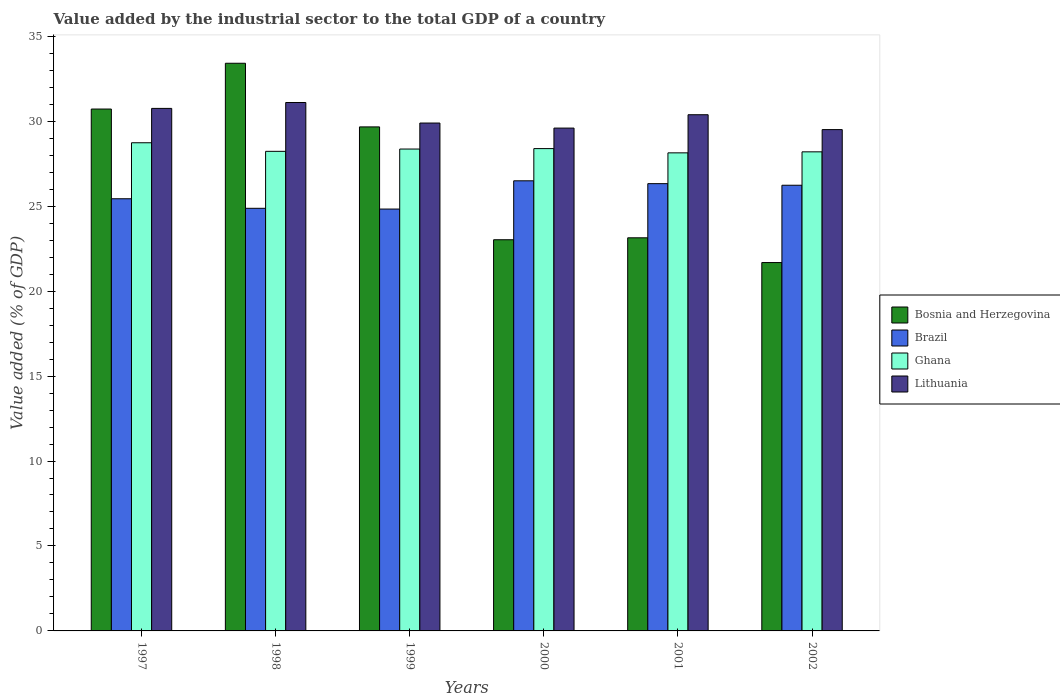How many groups of bars are there?
Provide a short and direct response. 6. How many bars are there on the 1st tick from the left?
Offer a very short reply. 4. In how many cases, is the number of bars for a given year not equal to the number of legend labels?
Keep it short and to the point. 0. What is the value added by the industrial sector to the total GDP in Brazil in 1997?
Your answer should be very brief. 25.44. Across all years, what is the maximum value added by the industrial sector to the total GDP in Ghana?
Ensure brevity in your answer.  28.73. Across all years, what is the minimum value added by the industrial sector to the total GDP in Ghana?
Your response must be concise. 28.14. In which year was the value added by the industrial sector to the total GDP in Brazil minimum?
Keep it short and to the point. 1999. What is the total value added by the industrial sector to the total GDP in Ghana in the graph?
Provide a succinct answer. 170.04. What is the difference between the value added by the industrial sector to the total GDP in Ghana in 1999 and that in 2002?
Provide a succinct answer. 0.16. What is the difference between the value added by the industrial sector to the total GDP in Ghana in 1997 and the value added by the industrial sector to the total GDP in Bosnia and Herzegovina in 2002?
Your response must be concise. 7.05. What is the average value added by the industrial sector to the total GDP in Lithuania per year?
Provide a succinct answer. 30.2. In the year 1999, what is the difference between the value added by the industrial sector to the total GDP in Brazil and value added by the industrial sector to the total GDP in Ghana?
Your answer should be very brief. -3.53. In how many years, is the value added by the industrial sector to the total GDP in Brazil greater than 11 %?
Provide a succinct answer. 6. What is the ratio of the value added by the industrial sector to the total GDP in Lithuania in 1999 to that in 2002?
Give a very brief answer. 1.01. Is the value added by the industrial sector to the total GDP in Lithuania in 2000 less than that in 2002?
Ensure brevity in your answer.  No. Is the difference between the value added by the industrial sector to the total GDP in Brazil in 2001 and 2002 greater than the difference between the value added by the industrial sector to the total GDP in Ghana in 2001 and 2002?
Provide a short and direct response. Yes. What is the difference between the highest and the second highest value added by the industrial sector to the total GDP in Bosnia and Herzegovina?
Offer a very short reply. 2.69. What is the difference between the highest and the lowest value added by the industrial sector to the total GDP in Ghana?
Make the answer very short. 0.59. Is the sum of the value added by the industrial sector to the total GDP in Brazil in 2000 and 2001 greater than the maximum value added by the industrial sector to the total GDP in Bosnia and Herzegovina across all years?
Offer a very short reply. Yes. What does the 3rd bar from the left in 2001 represents?
Provide a short and direct response. Ghana. What does the 1st bar from the right in 1999 represents?
Your answer should be very brief. Lithuania. Is it the case that in every year, the sum of the value added by the industrial sector to the total GDP in Ghana and value added by the industrial sector to the total GDP in Lithuania is greater than the value added by the industrial sector to the total GDP in Brazil?
Your answer should be very brief. Yes. Are all the bars in the graph horizontal?
Ensure brevity in your answer.  No. How many years are there in the graph?
Offer a very short reply. 6. Does the graph contain any zero values?
Your answer should be very brief. No. Does the graph contain grids?
Your response must be concise. No. How are the legend labels stacked?
Provide a succinct answer. Vertical. What is the title of the graph?
Offer a very short reply. Value added by the industrial sector to the total GDP of a country. Does "Europe(developing only)" appear as one of the legend labels in the graph?
Ensure brevity in your answer.  No. What is the label or title of the X-axis?
Offer a terse response. Years. What is the label or title of the Y-axis?
Keep it short and to the point. Value added (% of GDP). What is the Value added (% of GDP) in Bosnia and Herzegovina in 1997?
Offer a very short reply. 30.72. What is the Value added (% of GDP) in Brazil in 1997?
Ensure brevity in your answer.  25.44. What is the Value added (% of GDP) in Ghana in 1997?
Your answer should be very brief. 28.73. What is the Value added (% of GDP) in Lithuania in 1997?
Make the answer very short. 30.75. What is the Value added (% of GDP) of Bosnia and Herzegovina in 1998?
Your answer should be very brief. 33.41. What is the Value added (% of GDP) of Brazil in 1998?
Give a very brief answer. 24.87. What is the Value added (% of GDP) in Ghana in 1998?
Offer a terse response. 28.23. What is the Value added (% of GDP) in Lithuania in 1998?
Provide a short and direct response. 31.1. What is the Value added (% of GDP) in Bosnia and Herzegovina in 1999?
Keep it short and to the point. 29.66. What is the Value added (% of GDP) in Brazil in 1999?
Your response must be concise. 24.83. What is the Value added (% of GDP) of Ghana in 1999?
Keep it short and to the point. 28.36. What is the Value added (% of GDP) of Lithuania in 1999?
Keep it short and to the point. 29.89. What is the Value added (% of GDP) of Bosnia and Herzegovina in 2000?
Make the answer very short. 23.02. What is the Value added (% of GDP) of Brazil in 2000?
Provide a succinct answer. 26.49. What is the Value added (% of GDP) of Ghana in 2000?
Your answer should be compact. 28.39. What is the Value added (% of GDP) of Lithuania in 2000?
Give a very brief answer. 29.6. What is the Value added (% of GDP) in Bosnia and Herzegovina in 2001?
Offer a terse response. 23.14. What is the Value added (% of GDP) of Brazil in 2001?
Ensure brevity in your answer.  26.32. What is the Value added (% of GDP) in Ghana in 2001?
Your answer should be compact. 28.14. What is the Value added (% of GDP) in Lithuania in 2001?
Offer a very short reply. 30.38. What is the Value added (% of GDP) in Bosnia and Herzegovina in 2002?
Give a very brief answer. 21.68. What is the Value added (% of GDP) in Brazil in 2002?
Give a very brief answer. 26.23. What is the Value added (% of GDP) of Ghana in 2002?
Offer a very short reply. 28.2. What is the Value added (% of GDP) in Lithuania in 2002?
Ensure brevity in your answer.  29.51. Across all years, what is the maximum Value added (% of GDP) of Bosnia and Herzegovina?
Give a very brief answer. 33.41. Across all years, what is the maximum Value added (% of GDP) in Brazil?
Make the answer very short. 26.49. Across all years, what is the maximum Value added (% of GDP) of Ghana?
Your answer should be very brief. 28.73. Across all years, what is the maximum Value added (% of GDP) of Lithuania?
Keep it short and to the point. 31.1. Across all years, what is the minimum Value added (% of GDP) of Bosnia and Herzegovina?
Offer a terse response. 21.68. Across all years, what is the minimum Value added (% of GDP) of Brazil?
Give a very brief answer. 24.83. Across all years, what is the minimum Value added (% of GDP) of Ghana?
Your response must be concise. 28.14. Across all years, what is the minimum Value added (% of GDP) in Lithuania?
Provide a succinct answer. 29.51. What is the total Value added (% of GDP) of Bosnia and Herzegovina in the graph?
Keep it short and to the point. 161.63. What is the total Value added (% of GDP) in Brazil in the graph?
Your response must be concise. 154.19. What is the total Value added (% of GDP) in Ghana in the graph?
Offer a terse response. 170.04. What is the total Value added (% of GDP) in Lithuania in the graph?
Offer a very short reply. 181.23. What is the difference between the Value added (% of GDP) in Bosnia and Herzegovina in 1997 and that in 1998?
Offer a very short reply. -2.69. What is the difference between the Value added (% of GDP) in Brazil in 1997 and that in 1998?
Your answer should be compact. 0.56. What is the difference between the Value added (% of GDP) in Ghana in 1997 and that in 1998?
Offer a terse response. 0.51. What is the difference between the Value added (% of GDP) of Lithuania in 1997 and that in 1998?
Your answer should be compact. -0.35. What is the difference between the Value added (% of GDP) in Bosnia and Herzegovina in 1997 and that in 1999?
Provide a short and direct response. 1.05. What is the difference between the Value added (% of GDP) of Brazil in 1997 and that in 1999?
Provide a succinct answer. 0.61. What is the difference between the Value added (% of GDP) in Ghana in 1997 and that in 1999?
Offer a very short reply. 0.37. What is the difference between the Value added (% of GDP) in Lithuania in 1997 and that in 1999?
Provide a succinct answer. 0.86. What is the difference between the Value added (% of GDP) in Bosnia and Herzegovina in 1997 and that in 2000?
Provide a succinct answer. 7.69. What is the difference between the Value added (% of GDP) in Brazil in 1997 and that in 2000?
Keep it short and to the point. -1.06. What is the difference between the Value added (% of GDP) of Ghana in 1997 and that in 2000?
Your answer should be compact. 0.34. What is the difference between the Value added (% of GDP) of Lithuania in 1997 and that in 2000?
Provide a short and direct response. 1.16. What is the difference between the Value added (% of GDP) of Bosnia and Herzegovina in 1997 and that in 2001?
Make the answer very short. 7.58. What is the difference between the Value added (% of GDP) in Brazil in 1997 and that in 2001?
Your answer should be compact. -0.89. What is the difference between the Value added (% of GDP) in Ghana in 1997 and that in 2001?
Give a very brief answer. 0.59. What is the difference between the Value added (% of GDP) in Lithuania in 1997 and that in 2001?
Provide a short and direct response. 0.37. What is the difference between the Value added (% of GDP) in Bosnia and Herzegovina in 1997 and that in 2002?
Your answer should be compact. 9.03. What is the difference between the Value added (% of GDP) of Brazil in 1997 and that in 2002?
Give a very brief answer. -0.79. What is the difference between the Value added (% of GDP) in Ghana in 1997 and that in 2002?
Provide a succinct answer. 0.53. What is the difference between the Value added (% of GDP) in Lithuania in 1997 and that in 2002?
Make the answer very short. 1.25. What is the difference between the Value added (% of GDP) in Bosnia and Herzegovina in 1998 and that in 1999?
Your response must be concise. 3.75. What is the difference between the Value added (% of GDP) in Brazil in 1998 and that in 1999?
Your answer should be compact. 0.04. What is the difference between the Value added (% of GDP) in Ghana in 1998 and that in 1999?
Offer a very short reply. -0.14. What is the difference between the Value added (% of GDP) in Lithuania in 1998 and that in 1999?
Your answer should be compact. 1.21. What is the difference between the Value added (% of GDP) in Bosnia and Herzegovina in 1998 and that in 2000?
Ensure brevity in your answer.  10.39. What is the difference between the Value added (% of GDP) of Brazil in 1998 and that in 2000?
Your answer should be very brief. -1.62. What is the difference between the Value added (% of GDP) in Ghana in 1998 and that in 2000?
Ensure brevity in your answer.  -0.16. What is the difference between the Value added (% of GDP) in Lithuania in 1998 and that in 2000?
Your answer should be compact. 1.51. What is the difference between the Value added (% of GDP) of Bosnia and Herzegovina in 1998 and that in 2001?
Offer a very short reply. 10.27. What is the difference between the Value added (% of GDP) in Brazil in 1998 and that in 2001?
Provide a succinct answer. -1.45. What is the difference between the Value added (% of GDP) of Ghana in 1998 and that in 2001?
Your response must be concise. 0.09. What is the difference between the Value added (% of GDP) in Lithuania in 1998 and that in 2001?
Keep it short and to the point. 0.72. What is the difference between the Value added (% of GDP) in Bosnia and Herzegovina in 1998 and that in 2002?
Offer a very short reply. 11.73. What is the difference between the Value added (% of GDP) in Brazil in 1998 and that in 2002?
Your answer should be compact. -1.36. What is the difference between the Value added (% of GDP) of Ghana in 1998 and that in 2002?
Your response must be concise. 0.03. What is the difference between the Value added (% of GDP) in Lithuania in 1998 and that in 2002?
Your answer should be compact. 1.6. What is the difference between the Value added (% of GDP) of Bosnia and Herzegovina in 1999 and that in 2000?
Your answer should be compact. 6.64. What is the difference between the Value added (% of GDP) of Brazil in 1999 and that in 2000?
Provide a succinct answer. -1.66. What is the difference between the Value added (% of GDP) in Ghana in 1999 and that in 2000?
Your answer should be very brief. -0.03. What is the difference between the Value added (% of GDP) in Lithuania in 1999 and that in 2000?
Give a very brief answer. 0.3. What is the difference between the Value added (% of GDP) of Bosnia and Herzegovina in 1999 and that in 2001?
Your response must be concise. 6.53. What is the difference between the Value added (% of GDP) in Brazil in 1999 and that in 2001?
Give a very brief answer. -1.49. What is the difference between the Value added (% of GDP) of Ghana in 1999 and that in 2001?
Offer a very short reply. 0.22. What is the difference between the Value added (% of GDP) of Lithuania in 1999 and that in 2001?
Your answer should be compact. -0.49. What is the difference between the Value added (% of GDP) of Bosnia and Herzegovina in 1999 and that in 2002?
Provide a succinct answer. 7.98. What is the difference between the Value added (% of GDP) of Brazil in 1999 and that in 2002?
Provide a succinct answer. -1.4. What is the difference between the Value added (% of GDP) in Ghana in 1999 and that in 2002?
Offer a terse response. 0.16. What is the difference between the Value added (% of GDP) in Lithuania in 1999 and that in 2002?
Your answer should be very brief. 0.39. What is the difference between the Value added (% of GDP) of Bosnia and Herzegovina in 2000 and that in 2001?
Offer a very short reply. -0.11. What is the difference between the Value added (% of GDP) of Brazil in 2000 and that in 2001?
Give a very brief answer. 0.17. What is the difference between the Value added (% of GDP) of Ghana in 2000 and that in 2001?
Offer a very short reply. 0.25. What is the difference between the Value added (% of GDP) in Lithuania in 2000 and that in 2001?
Keep it short and to the point. -0.79. What is the difference between the Value added (% of GDP) in Bosnia and Herzegovina in 2000 and that in 2002?
Ensure brevity in your answer.  1.34. What is the difference between the Value added (% of GDP) of Brazil in 2000 and that in 2002?
Your response must be concise. 0.26. What is the difference between the Value added (% of GDP) of Ghana in 2000 and that in 2002?
Give a very brief answer. 0.19. What is the difference between the Value added (% of GDP) of Lithuania in 2000 and that in 2002?
Provide a short and direct response. 0.09. What is the difference between the Value added (% of GDP) of Bosnia and Herzegovina in 2001 and that in 2002?
Your answer should be compact. 1.46. What is the difference between the Value added (% of GDP) of Brazil in 2001 and that in 2002?
Ensure brevity in your answer.  0.09. What is the difference between the Value added (% of GDP) in Ghana in 2001 and that in 2002?
Provide a succinct answer. -0.06. What is the difference between the Value added (% of GDP) in Lithuania in 2001 and that in 2002?
Keep it short and to the point. 0.88. What is the difference between the Value added (% of GDP) of Bosnia and Herzegovina in 1997 and the Value added (% of GDP) of Brazil in 1998?
Provide a succinct answer. 5.84. What is the difference between the Value added (% of GDP) of Bosnia and Herzegovina in 1997 and the Value added (% of GDP) of Ghana in 1998?
Keep it short and to the point. 2.49. What is the difference between the Value added (% of GDP) in Bosnia and Herzegovina in 1997 and the Value added (% of GDP) in Lithuania in 1998?
Offer a terse response. -0.39. What is the difference between the Value added (% of GDP) in Brazil in 1997 and the Value added (% of GDP) in Ghana in 1998?
Ensure brevity in your answer.  -2.79. What is the difference between the Value added (% of GDP) of Brazil in 1997 and the Value added (% of GDP) of Lithuania in 1998?
Keep it short and to the point. -5.66. What is the difference between the Value added (% of GDP) in Ghana in 1997 and the Value added (% of GDP) in Lithuania in 1998?
Keep it short and to the point. -2.37. What is the difference between the Value added (% of GDP) of Bosnia and Herzegovina in 1997 and the Value added (% of GDP) of Brazil in 1999?
Provide a succinct answer. 5.89. What is the difference between the Value added (% of GDP) in Bosnia and Herzegovina in 1997 and the Value added (% of GDP) in Ghana in 1999?
Provide a short and direct response. 2.35. What is the difference between the Value added (% of GDP) in Bosnia and Herzegovina in 1997 and the Value added (% of GDP) in Lithuania in 1999?
Keep it short and to the point. 0.82. What is the difference between the Value added (% of GDP) in Brazil in 1997 and the Value added (% of GDP) in Ghana in 1999?
Offer a very short reply. -2.93. What is the difference between the Value added (% of GDP) of Brazil in 1997 and the Value added (% of GDP) of Lithuania in 1999?
Provide a short and direct response. -4.46. What is the difference between the Value added (% of GDP) of Ghana in 1997 and the Value added (% of GDP) of Lithuania in 1999?
Offer a very short reply. -1.16. What is the difference between the Value added (% of GDP) of Bosnia and Herzegovina in 1997 and the Value added (% of GDP) of Brazil in 2000?
Your response must be concise. 4.22. What is the difference between the Value added (% of GDP) in Bosnia and Herzegovina in 1997 and the Value added (% of GDP) in Ghana in 2000?
Make the answer very short. 2.33. What is the difference between the Value added (% of GDP) of Bosnia and Herzegovina in 1997 and the Value added (% of GDP) of Lithuania in 2000?
Your answer should be very brief. 1.12. What is the difference between the Value added (% of GDP) of Brazil in 1997 and the Value added (% of GDP) of Ghana in 2000?
Your answer should be very brief. -2.95. What is the difference between the Value added (% of GDP) in Brazil in 1997 and the Value added (% of GDP) in Lithuania in 2000?
Keep it short and to the point. -4.16. What is the difference between the Value added (% of GDP) in Ghana in 1997 and the Value added (% of GDP) in Lithuania in 2000?
Keep it short and to the point. -0.86. What is the difference between the Value added (% of GDP) of Bosnia and Herzegovina in 1997 and the Value added (% of GDP) of Brazil in 2001?
Give a very brief answer. 4.39. What is the difference between the Value added (% of GDP) in Bosnia and Herzegovina in 1997 and the Value added (% of GDP) in Ghana in 2001?
Offer a very short reply. 2.58. What is the difference between the Value added (% of GDP) in Bosnia and Herzegovina in 1997 and the Value added (% of GDP) in Lithuania in 2001?
Your answer should be compact. 0.33. What is the difference between the Value added (% of GDP) in Brazil in 1997 and the Value added (% of GDP) in Ghana in 2001?
Offer a very short reply. -2.7. What is the difference between the Value added (% of GDP) of Brazil in 1997 and the Value added (% of GDP) of Lithuania in 2001?
Your response must be concise. -4.95. What is the difference between the Value added (% of GDP) in Ghana in 1997 and the Value added (% of GDP) in Lithuania in 2001?
Provide a short and direct response. -1.65. What is the difference between the Value added (% of GDP) in Bosnia and Herzegovina in 1997 and the Value added (% of GDP) in Brazil in 2002?
Your answer should be very brief. 4.48. What is the difference between the Value added (% of GDP) in Bosnia and Herzegovina in 1997 and the Value added (% of GDP) in Ghana in 2002?
Make the answer very short. 2.52. What is the difference between the Value added (% of GDP) of Bosnia and Herzegovina in 1997 and the Value added (% of GDP) of Lithuania in 2002?
Offer a terse response. 1.21. What is the difference between the Value added (% of GDP) in Brazil in 1997 and the Value added (% of GDP) in Ghana in 2002?
Offer a very short reply. -2.76. What is the difference between the Value added (% of GDP) of Brazil in 1997 and the Value added (% of GDP) of Lithuania in 2002?
Offer a terse response. -4.07. What is the difference between the Value added (% of GDP) of Ghana in 1997 and the Value added (% of GDP) of Lithuania in 2002?
Provide a succinct answer. -0.77. What is the difference between the Value added (% of GDP) of Bosnia and Herzegovina in 1998 and the Value added (% of GDP) of Brazil in 1999?
Provide a short and direct response. 8.58. What is the difference between the Value added (% of GDP) in Bosnia and Herzegovina in 1998 and the Value added (% of GDP) in Ghana in 1999?
Keep it short and to the point. 5.05. What is the difference between the Value added (% of GDP) of Bosnia and Herzegovina in 1998 and the Value added (% of GDP) of Lithuania in 1999?
Ensure brevity in your answer.  3.52. What is the difference between the Value added (% of GDP) of Brazil in 1998 and the Value added (% of GDP) of Ghana in 1999?
Keep it short and to the point. -3.49. What is the difference between the Value added (% of GDP) in Brazil in 1998 and the Value added (% of GDP) in Lithuania in 1999?
Give a very brief answer. -5.02. What is the difference between the Value added (% of GDP) of Ghana in 1998 and the Value added (% of GDP) of Lithuania in 1999?
Give a very brief answer. -1.67. What is the difference between the Value added (% of GDP) in Bosnia and Herzegovina in 1998 and the Value added (% of GDP) in Brazil in 2000?
Offer a very short reply. 6.92. What is the difference between the Value added (% of GDP) of Bosnia and Herzegovina in 1998 and the Value added (% of GDP) of Ghana in 2000?
Make the answer very short. 5.02. What is the difference between the Value added (% of GDP) in Bosnia and Herzegovina in 1998 and the Value added (% of GDP) in Lithuania in 2000?
Ensure brevity in your answer.  3.82. What is the difference between the Value added (% of GDP) of Brazil in 1998 and the Value added (% of GDP) of Ghana in 2000?
Make the answer very short. -3.51. What is the difference between the Value added (% of GDP) of Brazil in 1998 and the Value added (% of GDP) of Lithuania in 2000?
Provide a succinct answer. -4.72. What is the difference between the Value added (% of GDP) of Ghana in 1998 and the Value added (% of GDP) of Lithuania in 2000?
Make the answer very short. -1.37. What is the difference between the Value added (% of GDP) of Bosnia and Herzegovina in 1998 and the Value added (% of GDP) of Brazil in 2001?
Ensure brevity in your answer.  7.09. What is the difference between the Value added (% of GDP) in Bosnia and Herzegovina in 1998 and the Value added (% of GDP) in Ghana in 2001?
Provide a succinct answer. 5.27. What is the difference between the Value added (% of GDP) of Bosnia and Herzegovina in 1998 and the Value added (% of GDP) of Lithuania in 2001?
Provide a succinct answer. 3.03. What is the difference between the Value added (% of GDP) in Brazil in 1998 and the Value added (% of GDP) in Ghana in 2001?
Provide a succinct answer. -3.26. What is the difference between the Value added (% of GDP) in Brazil in 1998 and the Value added (% of GDP) in Lithuania in 2001?
Your response must be concise. -5.51. What is the difference between the Value added (% of GDP) in Ghana in 1998 and the Value added (% of GDP) in Lithuania in 2001?
Offer a very short reply. -2.15. What is the difference between the Value added (% of GDP) of Bosnia and Herzegovina in 1998 and the Value added (% of GDP) of Brazil in 2002?
Offer a terse response. 7.18. What is the difference between the Value added (% of GDP) of Bosnia and Herzegovina in 1998 and the Value added (% of GDP) of Ghana in 2002?
Your answer should be compact. 5.21. What is the difference between the Value added (% of GDP) in Bosnia and Herzegovina in 1998 and the Value added (% of GDP) in Lithuania in 2002?
Make the answer very short. 3.9. What is the difference between the Value added (% of GDP) of Brazil in 1998 and the Value added (% of GDP) of Ghana in 2002?
Give a very brief answer. -3.32. What is the difference between the Value added (% of GDP) of Brazil in 1998 and the Value added (% of GDP) of Lithuania in 2002?
Make the answer very short. -4.63. What is the difference between the Value added (% of GDP) in Ghana in 1998 and the Value added (% of GDP) in Lithuania in 2002?
Your response must be concise. -1.28. What is the difference between the Value added (% of GDP) of Bosnia and Herzegovina in 1999 and the Value added (% of GDP) of Brazil in 2000?
Provide a short and direct response. 3.17. What is the difference between the Value added (% of GDP) in Bosnia and Herzegovina in 1999 and the Value added (% of GDP) in Ghana in 2000?
Provide a short and direct response. 1.28. What is the difference between the Value added (% of GDP) in Bosnia and Herzegovina in 1999 and the Value added (% of GDP) in Lithuania in 2000?
Make the answer very short. 0.07. What is the difference between the Value added (% of GDP) in Brazil in 1999 and the Value added (% of GDP) in Ghana in 2000?
Offer a very short reply. -3.56. What is the difference between the Value added (% of GDP) of Brazil in 1999 and the Value added (% of GDP) of Lithuania in 2000?
Ensure brevity in your answer.  -4.77. What is the difference between the Value added (% of GDP) of Ghana in 1999 and the Value added (% of GDP) of Lithuania in 2000?
Provide a succinct answer. -1.23. What is the difference between the Value added (% of GDP) in Bosnia and Herzegovina in 1999 and the Value added (% of GDP) in Brazil in 2001?
Make the answer very short. 3.34. What is the difference between the Value added (% of GDP) of Bosnia and Herzegovina in 1999 and the Value added (% of GDP) of Ghana in 2001?
Your answer should be very brief. 1.53. What is the difference between the Value added (% of GDP) in Bosnia and Herzegovina in 1999 and the Value added (% of GDP) in Lithuania in 2001?
Keep it short and to the point. -0.72. What is the difference between the Value added (% of GDP) of Brazil in 1999 and the Value added (% of GDP) of Ghana in 2001?
Your answer should be very brief. -3.31. What is the difference between the Value added (% of GDP) of Brazil in 1999 and the Value added (% of GDP) of Lithuania in 2001?
Offer a very short reply. -5.55. What is the difference between the Value added (% of GDP) in Ghana in 1999 and the Value added (% of GDP) in Lithuania in 2001?
Make the answer very short. -2.02. What is the difference between the Value added (% of GDP) of Bosnia and Herzegovina in 1999 and the Value added (% of GDP) of Brazil in 2002?
Make the answer very short. 3.43. What is the difference between the Value added (% of GDP) of Bosnia and Herzegovina in 1999 and the Value added (% of GDP) of Ghana in 2002?
Ensure brevity in your answer.  1.47. What is the difference between the Value added (% of GDP) in Bosnia and Herzegovina in 1999 and the Value added (% of GDP) in Lithuania in 2002?
Keep it short and to the point. 0.16. What is the difference between the Value added (% of GDP) of Brazil in 1999 and the Value added (% of GDP) of Ghana in 2002?
Keep it short and to the point. -3.37. What is the difference between the Value added (% of GDP) of Brazil in 1999 and the Value added (% of GDP) of Lithuania in 2002?
Offer a very short reply. -4.68. What is the difference between the Value added (% of GDP) in Ghana in 1999 and the Value added (% of GDP) in Lithuania in 2002?
Offer a very short reply. -1.14. What is the difference between the Value added (% of GDP) of Bosnia and Herzegovina in 2000 and the Value added (% of GDP) of Brazil in 2001?
Your answer should be compact. -3.3. What is the difference between the Value added (% of GDP) in Bosnia and Herzegovina in 2000 and the Value added (% of GDP) in Ghana in 2001?
Make the answer very short. -5.11. What is the difference between the Value added (% of GDP) of Bosnia and Herzegovina in 2000 and the Value added (% of GDP) of Lithuania in 2001?
Your answer should be very brief. -7.36. What is the difference between the Value added (% of GDP) in Brazil in 2000 and the Value added (% of GDP) in Ghana in 2001?
Give a very brief answer. -1.65. What is the difference between the Value added (% of GDP) in Brazil in 2000 and the Value added (% of GDP) in Lithuania in 2001?
Ensure brevity in your answer.  -3.89. What is the difference between the Value added (% of GDP) of Ghana in 2000 and the Value added (% of GDP) of Lithuania in 2001?
Provide a succinct answer. -1.99. What is the difference between the Value added (% of GDP) of Bosnia and Herzegovina in 2000 and the Value added (% of GDP) of Brazil in 2002?
Make the answer very short. -3.21. What is the difference between the Value added (% of GDP) of Bosnia and Herzegovina in 2000 and the Value added (% of GDP) of Ghana in 2002?
Your response must be concise. -5.17. What is the difference between the Value added (% of GDP) of Bosnia and Herzegovina in 2000 and the Value added (% of GDP) of Lithuania in 2002?
Offer a terse response. -6.48. What is the difference between the Value added (% of GDP) of Brazil in 2000 and the Value added (% of GDP) of Ghana in 2002?
Make the answer very short. -1.71. What is the difference between the Value added (% of GDP) in Brazil in 2000 and the Value added (% of GDP) in Lithuania in 2002?
Offer a very short reply. -3.01. What is the difference between the Value added (% of GDP) in Ghana in 2000 and the Value added (% of GDP) in Lithuania in 2002?
Offer a very short reply. -1.12. What is the difference between the Value added (% of GDP) of Bosnia and Herzegovina in 2001 and the Value added (% of GDP) of Brazil in 2002?
Give a very brief answer. -3.09. What is the difference between the Value added (% of GDP) in Bosnia and Herzegovina in 2001 and the Value added (% of GDP) in Ghana in 2002?
Offer a terse response. -5.06. What is the difference between the Value added (% of GDP) of Bosnia and Herzegovina in 2001 and the Value added (% of GDP) of Lithuania in 2002?
Provide a succinct answer. -6.37. What is the difference between the Value added (% of GDP) in Brazil in 2001 and the Value added (% of GDP) in Ghana in 2002?
Your answer should be compact. -1.87. What is the difference between the Value added (% of GDP) of Brazil in 2001 and the Value added (% of GDP) of Lithuania in 2002?
Your answer should be very brief. -3.18. What is the difference between the Value added (% of GDP) in Ghana in 2001 and the Value added (% of GDP) in Lithuania in 2002?
Provide a short and direct response. -1.37. What is the average Value added (% of GDP) of Bosnia and Herzegovina per year?
Make the answer very short. 26.94. What is the average Value added (% of GDP) in Brazil per year?
Offer a very short reply. 25.7. What is the average Value added (% of GDP) of Ghana per year?
Offer a very short reply. 28.34. What is the average Value added (% of GDP) in Lithuania per year?
Your answer should be compact. 30.2. In the year 1997, what is the difference between the Value added (% of GDP) of Bosnia and Herzegovina and Value added (% of GDP) of Brazil?
Provide a short and direct response. 5.28. In the year 1997, what is the difference between the Value added (% of GDP) in Bosnia and Herzegovina and Value added (% of GDP) in Ghana?
Ensure brevity in your answer.  1.98. In the year 1997, what is the difference between the Value added (% of GDP) of Bosnia and Herzegovina and Value added (% of GDP) of Lithuania?
Your answer should be very brief. -0.04. In the year 1997, what is the difference between the Value added (% of GDP) of Brazil and Value added (% of GDP) of Ghana?
Ensure brevity in your answer.  -3.3. In the year 1997, what is the difference between the Value added (% of GDP) of Brazil and Value added (% of GDP) of Lithuania?
Provide a succinct answer. -5.32. In the year 1997, what is the difference between the Value added (% of GDP) of Ghana and Value added (% of GDP) of Lithuania?
Your answer should be very brief. -2.02. In the year 1998, what is the difference between the Value added (% of GDP) in Bosnia and Herzegovina and Value added (% of GDP) in Brazil?
Ensure brevity in your answer.  8.54. In the year 1998, what is the difference between the Value added (% of GDP) in Bosnia and Herzegovina and Value added (% of GDP) in Ghana?
Make the answer very short. 5.18. In the year 1998, what is the difference between the Value added (% of GDP) of Bosnia and Herzegovina and Value added (% of GDP) of Lithuania?
Your response must be concise. 2.31. In the year 1998, what is the difference between the Value added (% of GDP) in Brazil and Value added (% of GDP) in Ghana?
Provide a short and direct response. -3.35. In the year 1998, what is the difference between the Value added (% of GDP) of Brazil and Value added (% of GDP) of Lithuania?
Make the answer very short. -6.23. In the year 1998, what is the difference between the Value added (% of GDP) of Ghana and Value added (% of GDP) of Lithuania?
Make the answer very short. -2.87. In the year 1999, what is the difference between the Value added (% of GDP) in Bosnia and Herzegovina and Value added (% of GDP) in Brazil?
Offer a very short reply. 4.83. In the year 1999, what is the difference between the Value added (% of GDP) in Bosnia and Herzegovina and Value added (% of GDP) in Ghana?
Your response must be concise. 1.3. In the year 1999, what is the difference between the Value added (% of GDP) in Bosnia and Herzegovina and Value added (% of GDP) in Lithuania?
Offer a terse response. -0.23. In the year 1999, what is the difference between the Value added (% of GDP) in Brazil and Value added (% of GDP) in Ghana?
Provide a short and direct response. -3.53. In the year 1999, what is the difference between the Value added (% of GDP) in Brazil and Value added (% of GDP) in Lithuania?
Keep it short and to the point. -5.06. In the year 1999, what is the difference between the Value added (% of GDP) in Ghana and Value added (% of GDP) in Lithuania?
Offer a very short reply. -1.53. In the year 2000, what is the difference between the Value added (% of GDP) in Bosnia and Herzegovina and Value added (% of GDP) in Brazil?
Offer a very short reply. -3.47. In the year 2000, what is the difference between the Value added (% of GDP) in Bosnia and Herzegovina and Value added (% of GDP) in Ghana?
Provide a short and direct response. -5.36. In the year 2000, what is the difference between the Value added (% of GDP) in Bosnia and Herzegovina and Value added (% of GDP) in Lithuania?
Offer a very short reply. -6.57. In the year 2000, what is the difference between the Value added (% of GDP) of Brazil and Value added (% of GDP) of Ghana?
Give a very brief answer. -1.89. In the year 2000, what is the difference between the Value added (% of GDP) of Brazil and Value added (% of GDP) of Lithuania?
Give a very brief answer. -3.1. In the year 2000, what is the difference between the Value added (% of GDP) of Ghana and Value added (% of GDP) of Lithuania?
Your response must be concise. -1.21. In the year 2001, what is the difference between the Value added (% of GDP) in Bosnia and Herzegovina and Value added (% of GDP) in Brazil?
Ensure brevity in your answer.  -3.19. In the year 2001, what is the difference between the Value added (% of GDP) of Bosnia and Herzegovina and Value added (% of GDP) of Ghana?
Ensure brevity in your answer.  -5. In the year 2001, what is the difference between the Value added (% of GDP) of Bosnia and Herzegovina and Value added (% of GDP) of Lithuania?
Offer a very short reply. -7.24. In the year 2001, what is the difference between the Value added (% of GDP) of Brazil and Value added (% of GDP) of Ghana?
Your answer should be compact. -1.81. In the year 2001, what is the difference between the Value added (% of GDP) of Brazil and Value added (% of GDP) of Lithuania?
Your response must be concise. -4.06. In the year 2001, what is the difference between the Value added (% of GDP) of Ghana and Value added (% of GDP) of Lithuania?
Give a very brief answer. -2.24. In the year 2002, what is the difference between the Value added (% of GDP) in Bosnia and Herzegovina and Value added (% of GDP) in Brazil?
Keep it short and to the point. -4.55. In the year 2002, what is the difference between the Value added (% of GDP) of Bosnia and Herzegovina and Value added (% of GDP) of Ghana?
Your response must be concise. -6.52. In the year 2002, what is the difference between the Value added (% of GDP) of Bosnia and Herzegovina and Value added (% of GDP) of Lithuania?
Offer a very short reply. -7.82. In the year 2002, what is the difference between the Value added (% of GDP) in Brazil and Value added (% of GDP) in Ghana?
Give a very brief answer. -1.97. In the year 2002, what is the difference between the Value added (% of GDP) in Brazil and Value added (% of GDP) in Lithuania?
Ensure brevity in your answer.  -3.27. In the year 2002, what is the difference between the Value added (% of GDP) of Ghana and Value added (% of GDP) of Lithuania?
Provide a succinct answer. -1.31. What is the ratio of the Value added (% of GDP) of Bosnia and Herzegovina in 1997 to that in 1998?
Your answer should be compact. 0.92. What is the ratio of the Value added (% of GDP) in Brazil in 1997 to that in 1998?
Provide a succinct answer. 1.02. What is the ratio of the Value added (% of GDP) of Ghana in 1997 to that in 1998?
Ensure brevity in your answer.  1.02. What is the ratio of the Value added (% of GDP) in Lithuania in 1997 to that in 1998?
Keep it short and to the point. 0.99. What is the ratio of the Value added (% of GDP) of Bosnia and Herzegovina in 1997 to that in 1999?
Ensure brevity in your answer.  1.04. What is the ratio of the Value added (% of GDP) of Brazil in 1997 to that in 1999?
Give a very brief answer. 1.02. What is the ratio of the Value added (% of GDP) in Ghana in 1997 to that in 1999?
Your answer should be compact. 1.01. What is the ratio of the Value added (% of GDP) in Lithuania in 1997 to that in 1999?
Provide a succinct answer. 1.03. What is the ratio of the Value added (% of GDP) in Bosnia and Herzegovina in 1997 to that in 2000?
Your response must be concise. 1.33. What is the ratio of the Value added (% of GDP) of Brazil in 1997 to that in 2000?
Offer a terse response. 0.96. What is the ratio of the Value added (% of GDP) in Ghana in 1997 to that in 2000?
Offer a terse response. 1.01. What is the ratio of the Value added (% of GDP) in Lithuania in 1997 to that in 2000?
Make the answer very short. 1.04. What is the ratio of the Value added (% of GDP) of Bosnia and Herzegovina in 1997 to that in 2001?
Offer a very short reply. 1.33. What is the ratio of the Value added (% of GDP) in Brazil in 1997 to that in 2001?
Your response must be concise. 0.97. What is the ratio of the Value added (% of GDP) of Ghana in 1997 to that in 2001?
Provide a short and direct response. 1.02. What is the ratio of the Value added (% of GDP) in Lithuania in 1997 to that in 2001?
Give a very brief answer. 1.01. What is the ratio of the Value added (% of GDP) of Bosnia and Herzegovina in 1997 to that in 2002?
Your answer should be very brief. 1.42. What is the ratio of the Value added (% of GDP) of Brazil in 1997 to that in 2002?
Your answer should be very brief. 0.97. What is the ratio of the Value added (% of GDP) in Ghana in 1997 to that in 2002?
Give a very brief answer. 1.02. What is the ratio of the Value added (% of GDP) in Lithuania in 1997 to that in 2002?
Offer a very short reply. 1.04. What is the ratio of the Value added (% of GDP) in Bosnia and Herzegovina in 1998 to that in 1999?
Your response must be concise. 1.13. What is the ratio of the Value added (% of GDP) in Ghana in 1998 to that in 1999?
Ensure brevity in your answer.  1. What is the ratio of the Value added (% of GDP) in Lithuania in 1998 to that in 1999?
Your response must be concise. 1.04. What is the ratio of the Value added (% of GDP) of Bosnia and Herzegovina in 1998 to that in 2000?
Make the answer very short. 1.45. What is the ratio of the Value added (% of GDP) of Brazil in 1998 to that in 2000?
Provide a short and direct response. 0.94. What is the ratio of the Value added (% of GDP) in Ghana in 1998 to that in 2000?
Provide a succinct answer. 0.99. What is the ratio of the Value added (% of GDP) in Lithuania in 1998 to that in 2000?
Offer a terse response. 1.05. What is the ratio of the Value added (% of GDP) of Bosnia and Herzegovina in 1998 to that in 2001?
Provide a short and direct response. 1.44. What is the ratio of the Value added (% of GDP) in Brazil in 1998 to that in 2001?
Make the answer very short. 0.94. What is the ratio of the Value added (% of GDP) in Ghana in 1998 to that in 2001?
Your response must be concise. 1. What is the ratio of the Value added (% of GDP) of Lithuania in 1998 to that in 2001?
Ensure brevity in your answer.  1.02. What is the ratio of the Value added (% of GDP) of Bosnia and Herzegovina in 1998 to that in 2002?
Ensure brevity in your answer.  1.54. What is the ratio of the Value added (% of GDP) of Brazil in 1998 to that in 2002?
Offer a very short reply. 0.95. What is the ratio of the Value added (% of GDP) in Ghana in 1998 to that in 2002?
Your answer should be compact. 1. What is the ratio of the Value added (% of GDP) of Lithuania in 1998 to that in 2002?
Your response must be concise. 1.05. What is the ratio of the Value added (% of GDP) of Bosnia and Herzegovina in 1999 to that in 2000?
Your response must be concise. 1.29. What is the ratio of the Value added (% of GDP) in Brazil in 1999 to that in 2000?
Offer a very short reply. 0.94. What is the ratio of the Value added (% of GDP) of Bosnia and Herzegovina in 1999 to that in 2001?
Provide a short and direct response. 1.28. What is the ratio of the Value added (% of GDP) in Brazil in 1999 to that in 2001?
Give a very brief answer. 0.94. What is the ratio of the Value added (% of GDP) of Lithuania in 1999 to that in 2001?
Your answer should be compact. 0.98. What is the ratio of the Value added (% of GDP) of Bosnia and Herzegovina in 1999 to that in 2002?
Provide a succinct answer. 1.37. What is the ratio of the Value added (% of GDP) in Brazil in 1999 to that in 2002?
Your response must be concise. 0.95. What is the ratio of the Value added (% of GDP) of Ghana in 1999 to that in 2002?
Your answer should be very brief. 1.01. What is the ratio of the Value added (% of GDP) of Lithuania in 1999 to that in 2002?
Your answer should be compact. 1.01. What is the ratio of the Value added (% of GDP) in Bosnia and Herzegovina in 2000 to that in 2001?
Provide a succinct answer. 1. What is the ratio of the Value added (% of GDP) of Brazil in 2000 to that in 2001?
Offer a very short reply. 1.01. What is the ratio of the Value added (% of GDP) of Ghana in 2000 to that in 2001?
Keep it short and to the point. 1.01. What is the ratio of the Value added (% of GDP) in Lithuania in 2000 to that in 2001?
Ensure brevity in your answer.  0.97. What is the ratio of the Value added (% of GDP) of Bosnia and Herzegovina in 2000 to that in 2002?
Make the answer very short. 1.06. What is the ratio of the Value added (% of GDP) of Ghana in 2000 to that in 2002?
Your answer should be very brief. 1.01. What is the ratio of the Value added (% of GDP) in Lithuania in 2000 to that in 2002?
Offer a terse response. 1. What is the ratio of the Value added (% of GDP) in Bosnia and Herzegovina in 2001 to that in 2002?
Provide a short and direct response. 1.07. What is the ratio of the Value added (% of GDP) in Brazil in 2001 to that in 2002?
Offer a terse response. 1. What is the ratio of the Value added (% of GDP) in Lithuania in 2001 to that in 2002?
Ensure brevity in your answer.  1.03. What is the difference between the highest and the second highest Value added (% of GDP) in Bosnia and Herzegovina?
Ensure brevity in your answer.  2.69. What is the difference between the highest and the second highest Value added (% of GDP) of Brazil?
Ensure brevity in your answer.  0.17. What is the difference between the highest and the second highest Value added (% of GDP) in Ghana?
Give a very brief answer. 0.34. What is the difference between the highest and the second highest Value added (% of GDP) in Lithuania?
Provide a succinct answer. 0.35. What is the difference between the highest and the lowest Value added (% of GDP) of Bosnia and Herzegovina?
Keep it short and to the point. 11.73. What is the difference between the highest and the lowest Value added (% of GDP) of Brazil?
Provide a succinct answer. 1.66. What is the difference between the highest and the lowest Value added (% of GDP) in Ghana?
Offer a terse response. 0.59. What is the difference between the highest and the lowest Value added (% of GDP) of Lithuania?
Your answer should be compact. 1.6. 